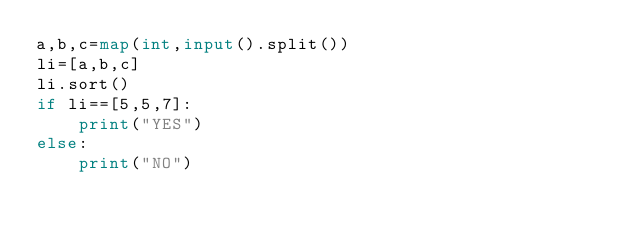<code> <loc_0><loc_0><loc_500><loc_500><_Python_>a,b,c=map(int,input().split())
li=[a,b,c]
li.sort()
if li==[5,5,7]:
    print("YES")
else:
    print("NO")</code> 